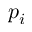Convert formula to latex. <formula><loc_0><loc_0><loc_500><loc_500>p _ { i }</formula> 